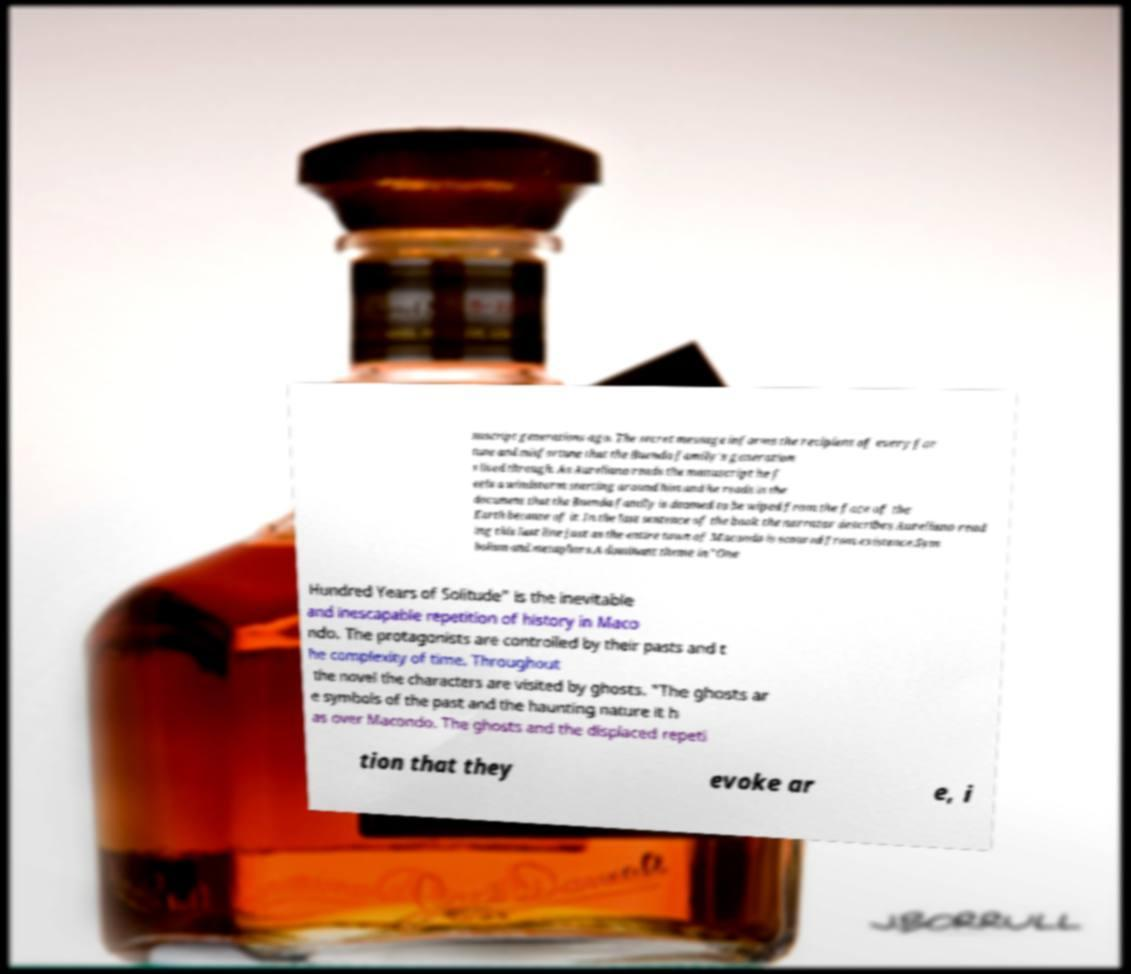For documentation purposes, I need the text within this image transcribed. Could you provide that? nuscript generations ago. The secret message informs the recipient of every for tune and misfortune that the Buenda family's generation s lived through. As Aureliano reads the manuscript he f eels a windstorm starting around him and he reads in the document that the Buenda family is doomed to be wiped from the face of the Earth because of it. In the last sentence of the book the narrator describes Aureliano read ing this last line just as the entire town of Macondo is scoured from existence.Sym bolism and metaphors.A dominant theme in "One Hundred Years of Solitude" is the inevitable and inescapable repetition of history in Maco ndo. The protagonists are controlled by their pasts and t he complexity of time. Throughout the novel the characters are visited by ghosts. "The ghosts ar e symbols of the past and the haunting nature it h as over Macondo. The ghosts and the displaced repeti tion that they evoke ar e, i 